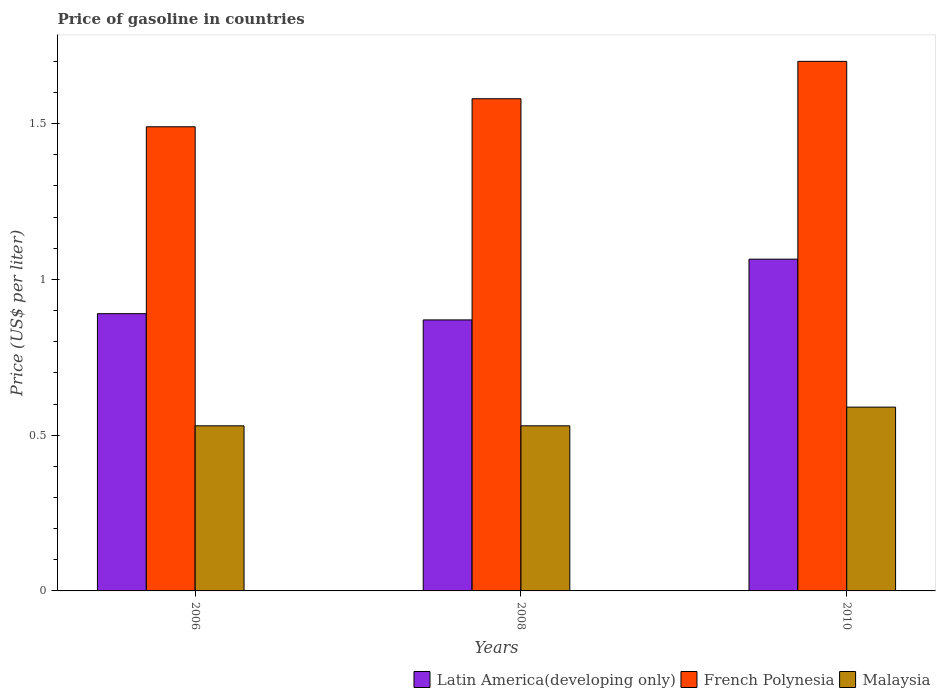How many different coloured bars are there?
Give a very brief answer. 3. Are the number of bars on each tick of the X-axis equal?
Keep it short and to the point. Yes. How many bars are there on the 1st tick from the left?
Keep it short and to the point. 3. How many bars are there on the 1st tick from the right?
Your answer should be very brief. 3. In how many cases, is the number of bars for a given year not equal to the number of legend labels?
Your answer should be compact. 0. What is the price of gasoline in French Polynesia in 2010?
Offer a terse response. 1.7. Across all years, what is the minimum price of gasoline in Malaysia?
Your response must be concise. 0.53. What is the total price of gasoline in Malaysia in the graph?
Give a very brief answer. 1.65. What is the difference between the price of gasoline in Malaysia in 2006 and that in 2008?
Provide a short and direct response. 0. What is the difference between the price of gasoline in French Polynesia in 2010 and the price of gasoline in Malaysia in 2006?
Provide a succinct answer. 1.17. What is the average price of gasoline in French Polynesia per year?
Your answer should be very brief. 1.59. What is the ratio of the price of gasoline in French Polynesia in 2008 to that in 2010?
Ensure brevity in your answer.  0.93. Is the price of gasoline in Malaysia in 2006 less than that in 2010?
Keep it short and to the point. Yes. Is the difference between the price of gasoline in French Polynesia in 2008 and 2010 greater than the difference between the price of gasoline in Malaysia in 2008 and 2010?
Your answer should be compact. No. What is the difference between the highest and the second highest price of gasoline in French Polynesia?
Your answer should be very brief. 0.12. What is the difference between the highest and the lowest price of gasoline in Latin America(developing only)?
Your answer should be compact. 0.19. In how many years, is the price of gasoline in Latin America(developing only) greater than the average price of gasoline in Latin America(developing only) taken over all years?
Make the answer very short. 1. What does the 2nd bar from the left in 2008 represents?
Your answer should be compact. French Polynesia. What does the 2nd bar from the right in 2010 represents?
Provide a succinct answer. French Polynesia. Is it the case that in every year, the sum of the price of gasoline in French Polynesia and price of gasoline in Latin America(developing only) is greater than the price of gasoline in Malaysia?
Your answer should be compact. Yes. What is the difference between two consecutive major ticks on the Y-axis?
Make the answer very short. 0.5. Are the values on the major ticks of Y-axis written in scientific E-notation?
Your answer should be compact. No. Where does the legend appear in the graph?
Your answer should be very brief. Bottom right. How many legend labels are there?
Provide a short and direct response. 3. How are the legend labels stacked?
Your answer should be compact. Horizontal. What is the title of the graph?
Provide a succinct answer. Price of gasoline in countries. What is the label or title of the Y-axis?
Provide a short and direct response. Price (US$ per liter). What is the Price (US$ per liter) of Latin America(developing only) in 2006?
Your answer should be very brief. 0.89. What is the Price (US$ per liter) of French Polynesia in 2006?
Your response must be concise. 1.49. What is the Price (US$ per liter) of Malaysia in 2006?
Offer a very short reply. 0.53. What is the Price (US$ per liter) in Latin America(developing only) in 2008?
Make the answer very short. 0.87. What is the Price (US$ per liter) of French Polynesia in 2008?
Provide a short and direct response. 1.58. What is the Price (US$ per liter) in Malaysia in 2008?
Your response must be concise. 0.53. What is the Price (US$ per liter) of Latin America(developing only) in 2010?
Offer a terse response. 1.06. What is the Price (US$ per liter) in Malaysia in 2010?
Make the answer very short. 0.59. Across all years, what is the maximum Price (US$ per liter) in Latin America(developing only)?
Provide a short and direct response. 1.06. Across all years, what is the maximum Price (US$ per liter) in Malaysia?
Your answer should be very brief. 0.59. Across all years, what is the minimum Price (US$ per liter) of Latin America(developing only)?
Your answer should be very brief. 0.87. Across all years, what is the minimum Price (US$ per liter) in French Polynesia?
Provide a short and direct response. 1.49. Across all years, what is the minimum Price (US$ per liter) of Malaysia?
Provide a short and direct response. 0.53. What is the total Price (US$ per liter) in Latin America(developing only) in the graph?
Offer a very short reply. 2.83. What is the total Price (US$ per liter) in French Polynesia in the graph?
Keep it short and to the point. 4.77. What is the total Price (US$ per liter) in Malaysia in the graph?
Your response must be concise. 1.65. What is the difference between the Price (US$ per liter) of Latin America(developing only) in 2006 and that in 2008?
Your answer should be compact. 0.02. What is the difference between the Price (US$ per liter) of French Polynesia in 2006 and that in 2008?
Keep it short and to the point. -0.09. What is the difference between the Price (US$ per liter) of Malaysia in 2006 and that in 2008?
Give a very brief answer. 0. What is the difference between the Price (US$ per liter) in Latin America(developing only) in 2006 and that in 2010?
Give a very brief answer. -0.17. What is the difference between the Price (US$ per liter) in French Polynesia in 2006 and that in 2010?
Your response must be concise. -0.21. What is the difference between the Price (US$ per liter) in Malaysia in 2006 and that in 2010?
Ensure brevity in your answer.  -0.06. What is the difference between the Price (US$ per liter) in Latin America(developing only) in 2008 and that in 2010?
Keep it short and to the point. -0.2. What is the difference between the Price (US$ per liter) in French Polynesia in 2008 and that in 2010?
Provide a succinct answer. -0.12. What is the difference between the Price (US$ per liter) of Malaysia in 2008 and that in 2010?
Make the answer very short. -0.06. What is the difference between the Price (US$ per liter) in Latin America(developing only) in 2006 and the Price (US$ per liter) in French Polynesia in 2008?
Keep it short and to the point. -0.69. What is the difference between the Price (US$ per liter) in Latin America(developing only) in 2006 and the Price (US$ per liter) in Malaysia in 2008?
Keep it short and to the point. 0.36. What is the difference between the Price (US$ per liter) of French Polynesia in 2006 and the Price (US$ per liter) of Malaysia in 2008?
Offer a very short reply. 0.96. What is the difference between the Price (US$ per liter) in Latin America(developing only) in 2006 and the Price (US$ per liter) in French Polynesia in 2010?
Keep it short and to the point. -0.81. What is the difference between the Price (US$ per liter) in Latin America(developing only) in 2006 and the Price (US$ per liter) in Malaysia in 2010?
Offer a terse response. 0.3. What is the difference between the Price (US$ per liter) in French Polynesia in 2006 and the Price (US$ per liter) in Malaysia in 2010?
Your response must be concise. 0.9. What is the difference between the Price (US$ per liter) of Latin America(developing only) in 2008 and the Price (US$ per liter) of French Polynesia in 2010?
Provide a short and direct response. -0.83. What is the difference between the Price (US$ per liter) of Latin America(developing only) in 2008 and the Price (US$ per liter) of Malaysia in 2010?
Your response must be concise. 0.28. What is the difference between the Price (US$ per liter) in French Polynesia in 2008 and the Price (US$ per liter) in Malaysia in 2010?
Keep it short and to the point. 0.99. What is the average Price (US$ per liter) in Latin America(developing only) per year?
Provide a short and direct response. 0.94. What is the average Price (US$ per liter) of French Polynesia per year?
Your answer should be compact. 1.59. What is the average Price (US$ per liter) in Malaysia per year?
Keep it short and to the point. 0.55. In the year 2006, what is the difference between the Price (US$ per liter) in Latin America(developing only) and Price (US$ per liter) in French Polynesia?
Provide a short and direct response. -0.6. In the year 2006, what is the difference between the Price (US$ per liter) in Latin America(developing only) and Price (US$ per liter) in Malaysia?
Provide a succinct answer. 0.36. In the year 2008, what is the difference between the Price (US$ per liter) of Latin America(developing only) and Price (US$ per liter) of French Polynesia?
Provide a short and direct response. -0.71. In the year 2008, what is the difference between the Price (US$ per liter) in Latin America(developing only) and Price (US$ per liter) in Malaysia?
Ensure brevity in your answer.  0.34. In the year 2010, what is the difference between the Price (US$ per liter) of Latin America(developing only) and Price (US$ per liter) of French Polynesia?
Your answer should be compact. -0.64. In the year 2010, what is the difference between the Price (US$ per liter) of Latin America(developing only) and Price (US$ per liter) of Malaysia?
Your response must be concise. 0.47. In the year 2010, what is the difference between the Price (US$ per liter) in French Polynesia and Price (US$ per liter) in Malaysia?
Make the answer very short. 1.11. What is the ratio of the Price (US$ per liter) of Latin America(developing only) in 2006 to that in 2008?
Offer a very short reply. 1.02. What is the ratio of the Price (US$ per liter) in French Polynesia in 2006 to that in 2008?
Make the answer very short. 0.94. What is the ratio of the Price (US$ per liter) in Latin America(developing only) in 2006 to that in 2010?
Your answer should be compact. 0.84. What is the ratio of the Price (US$ per liter) of French Polynesia in 2006 to that in 2010?
Give a very brief answer. 0.88. What is the ratio of the Price (US$ per liter) of Malaysia in 2006 to that in 2010?
Ensure brevity in your answer.  0.9. What is the ratio of the Price (US$ per liter) in Latin America(developing only) in 2008 to that in 2010?
Offer a very short reply. 0.82. What is the ratio of the Price (US$ per liter) in French Polynesia in 2008 to that in 2010?
Keep it short and to the point. 0.93. What is the ratio of the Price (US$ per liter) of Malaysia in 2008 to that in 2010?
Offer a terse response. 0.9. What is the difference between the highest and the second highest Price (US$ per liter) of Latin America(developing only)?
Make the answer very short. 0.17. What is the difference between the highest and the second highest Price (US$ per liter) of French Polynesia?
Provide a short and direct response. 0.12. What is the difference between the highest and the lowest Price (US$ per liter) in Latin America(developing only)?
Your answer should be compact. 0.2. What is the difference between the highest and the lowest Price (US$ per liter) in French Polynesia?
Make the answer very short. 0.21. 